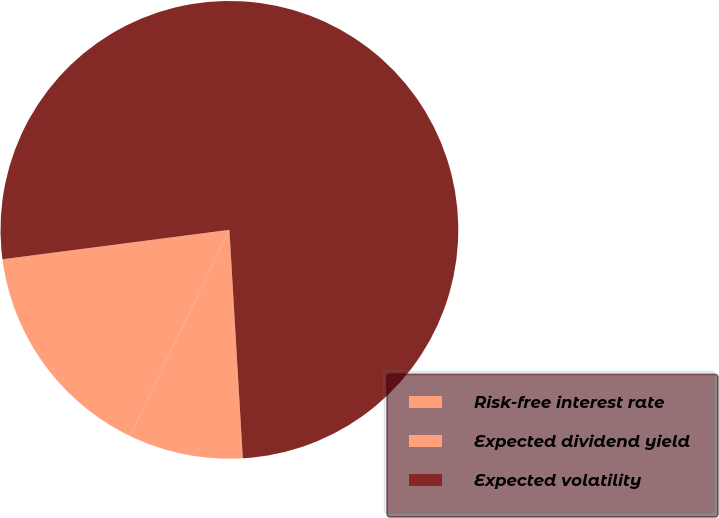Convert chart. <chart><loc_0><loc_0><loc_500><loc_500><pie_chart><fcel>Risk-free interest rate<fcel>Expected dividend yield<fcel>Expected volatility<nl><fcel>15.79%<fcel>8.09%<fcel>76.12%<nl></chart> 